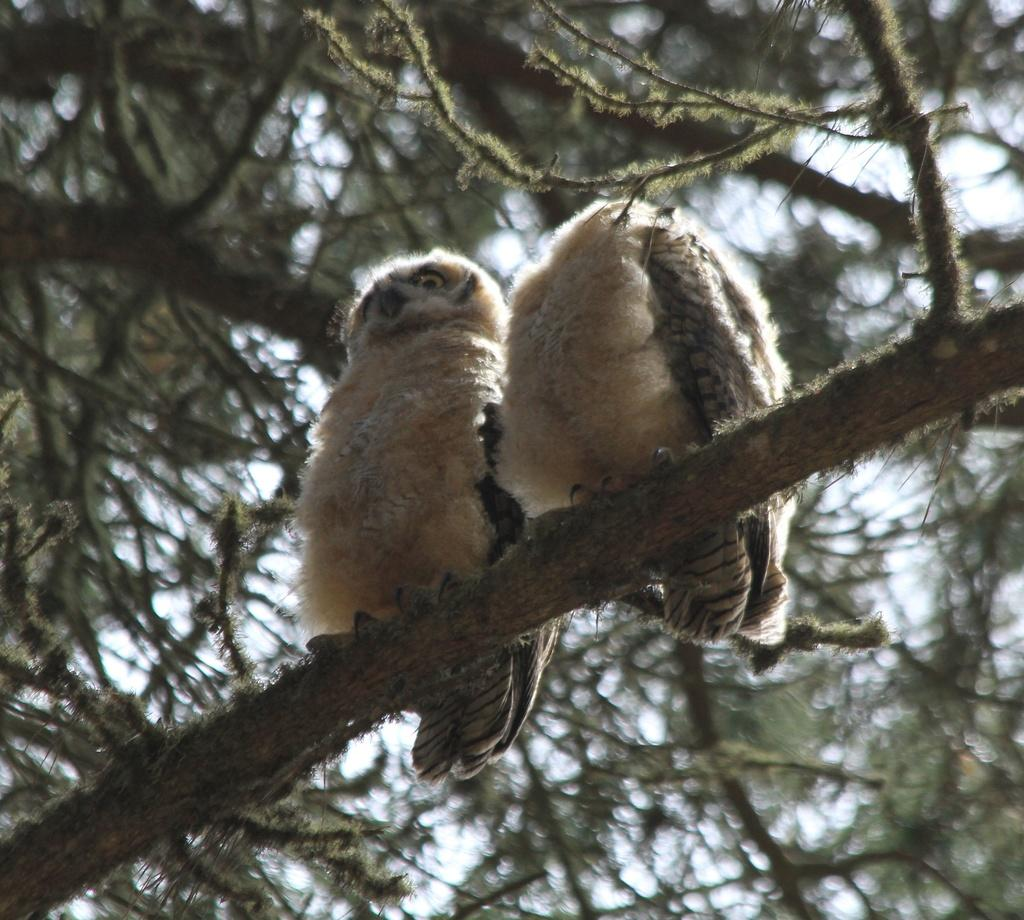How many birds are present in the image? There are two birds in the image. Where are the birds located? The birds are on the branch of a tree. What can be seen in the background of the image? The sky is visible in the background of the image. What type of juice is being served in the image? There is no juice present in the image; it features two birds on a tree branch. What treatment is being administered to the birds in the image? There is no treatment being administered to the birds in the image; they are simply perched on a tree branch. 